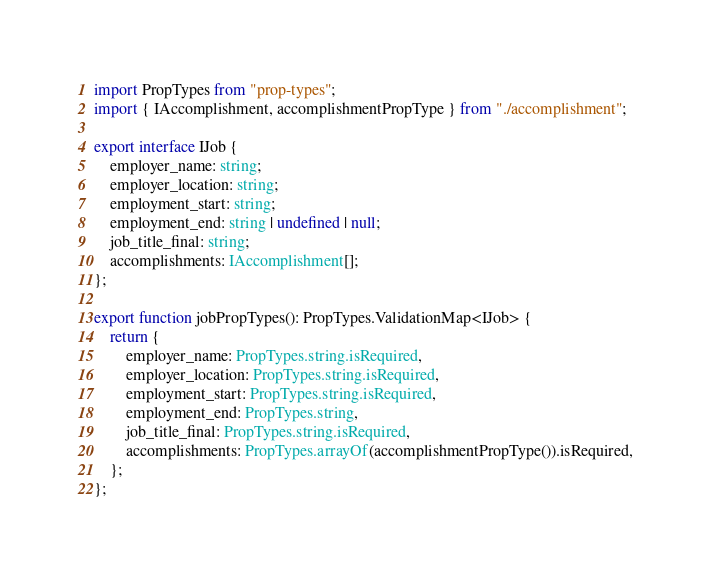Convert code to text. <code><loc_0><loc_0><loc_500><loc_500><_TypeScript_>import PropTypes from "prop-types";
import { IAccomplishment, accomplishmentPropType } from "./accomplishment";

export interface IJob {
    employer_name: string;
    employer_location: string;
    employment_start: string;
    employment_end: string | undefined | null;
    job_title_final: string;
    accomplishments: IAccomplishment[];
};

export function jobPropTypes(): PropTypes.ValidationMap<IJob> {
    return {
        employer_name: PropTypes.string.isRequired,
        employer_location: PropTypes.string.isRequired,
        employment_start: PropTypes.string.isRequired,
        employment_end: PropTypes.string,
        job_title_final: PropTypes.string.isRequired,
        accomplishments: PropTypes.arrayOf(accomplishmentPropType()).isRequired,
    };
};</code> 